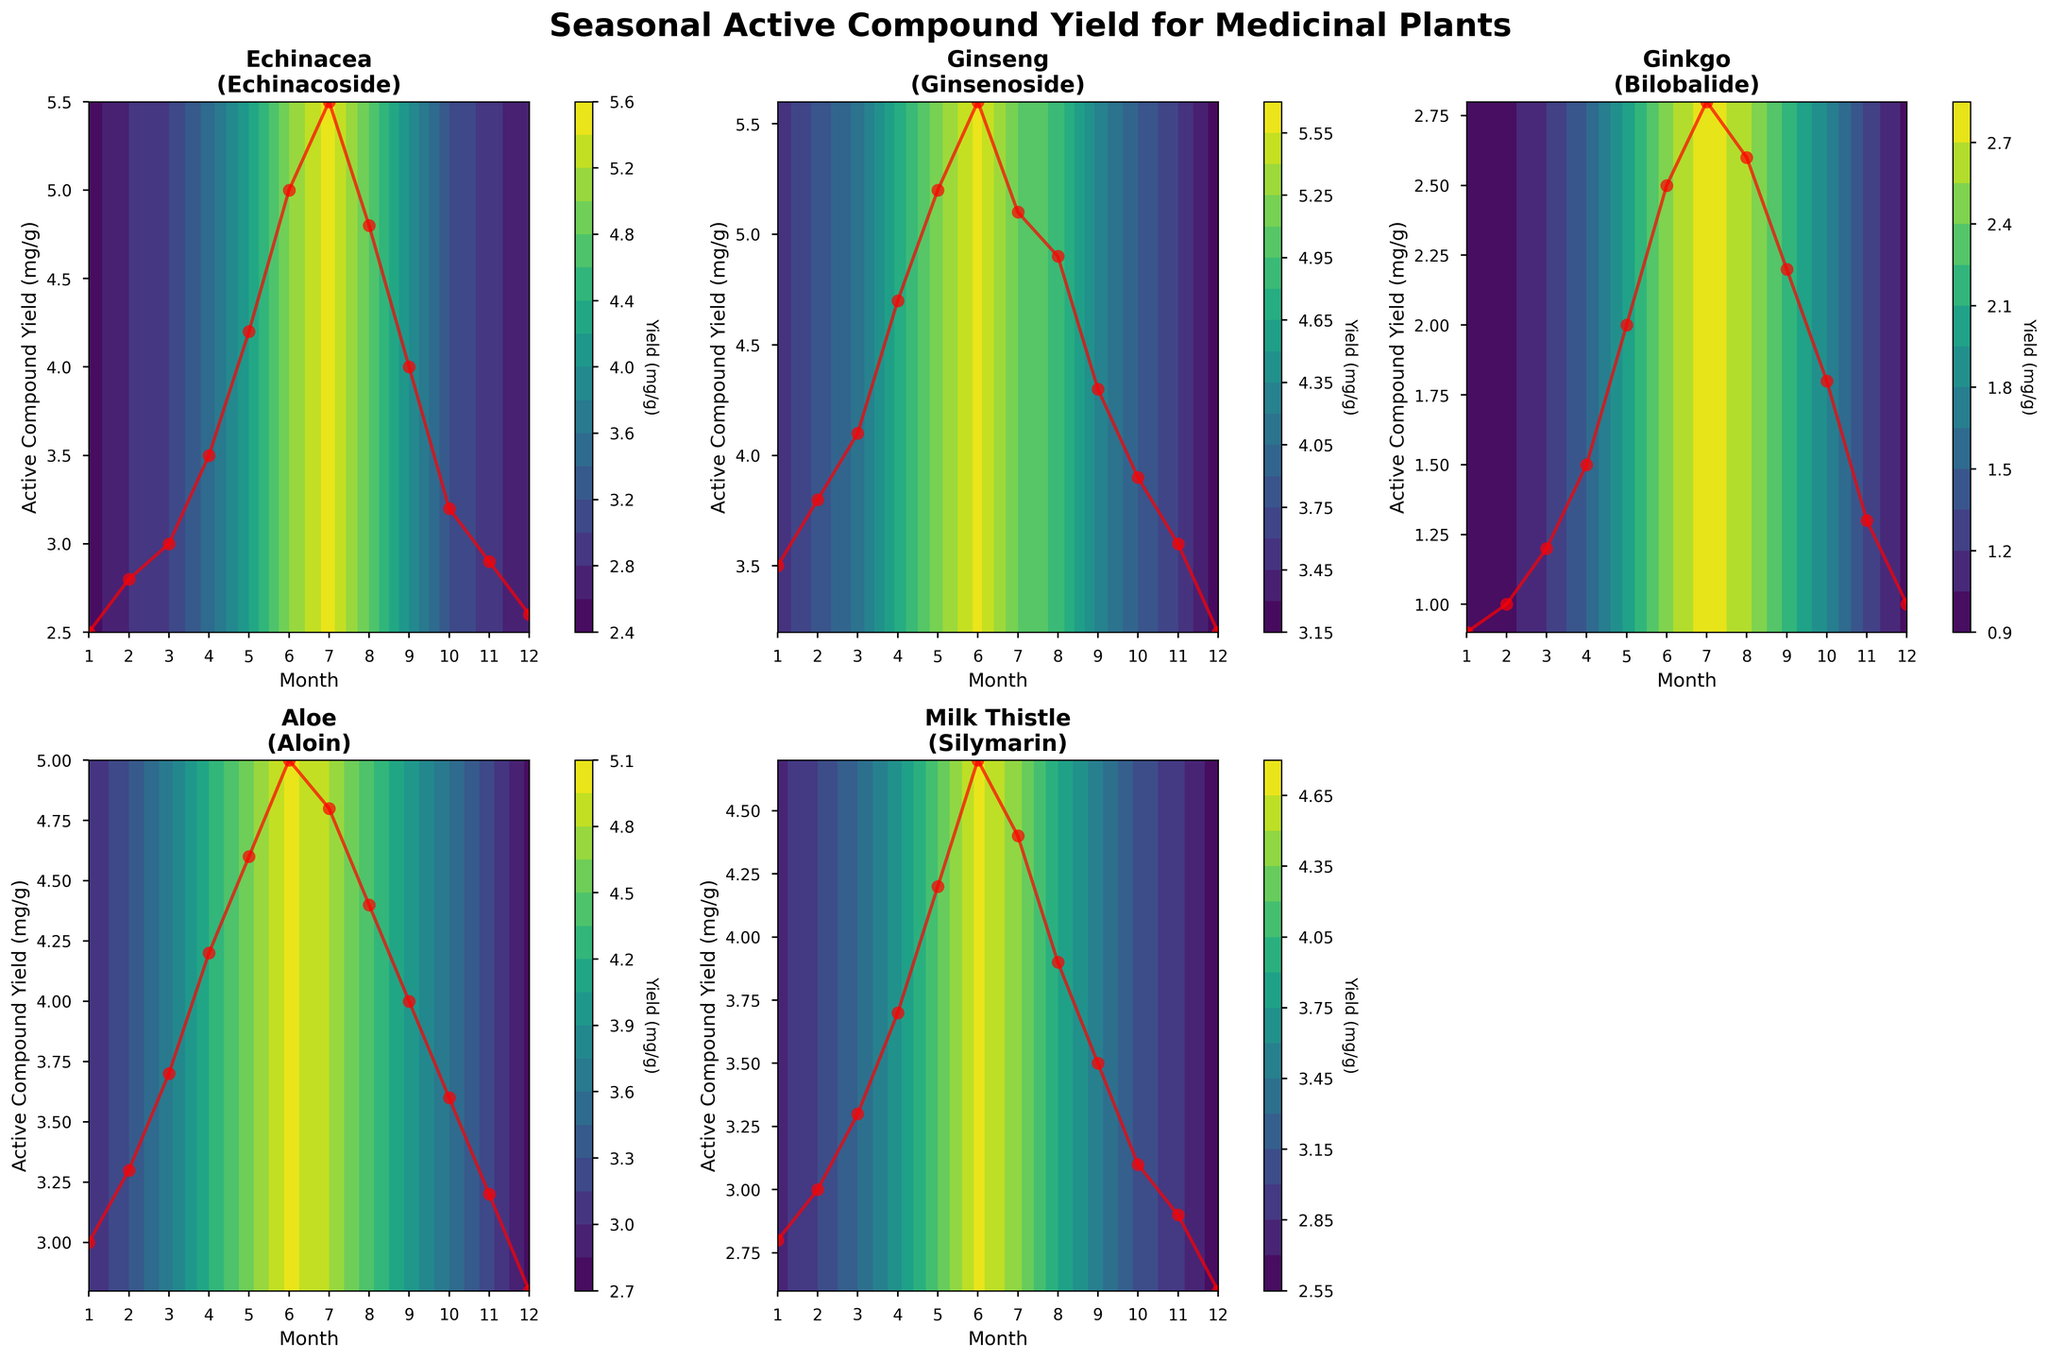How many medicinal plants are plotted in the figure? The figure has subplots for Echinacea, Ginseng, Ginkgo, Aloe, and Milk Thistle, totaling five medicinal plants.
Answer: 5 Which medicinal plant has the highest peak yield of its active compound? By looking at the peaks in the subplots, Echinacea and Ginseng both peak at around 5.5 mg/g and 5.6 mg/g, respectively. Ginseng's yield is slightly higher.
Answer: Ginseng What is the range of the active compound yield for Milk Thistle? The range can be determined by the minimum and maximum values on the y-axis of the subplot for Milk Thistle. The minimum yield is around 2.6 mg/g, and the maximum is around 4.7 mg/g.
Answer: 2.6 to 4.7 mg/g During which month does Aloe have its highest active compound yield? From the subplot for Aloe, the peak yield appears around June, which corresponds to month 6 on the x-axis.
Answer: June Which month generally sees a decrease in the active compound yield for most plants? By observing the trends across all subplots, it is evident that yields for Echinacea, Ginseng, Ginkgo, Aloe, and Milk Thistle generally decrease after their peak in June or July.
Answer: After July How does the yield of Bilobalide in Ginkgo change from January to December? The subplot for Ginkgo shows an overall increase in yield from January with 0.9 mg/g, peaking in July with 2.8 mg/g, and then a gradual decrease to 1.0 mg/g in December.
Answer: Increases then decreases During which month is Silymarin's yield at its lowest in Milk Thistle? In the subplot for Milk Thistle, the lowest yield occurs around December, where the yield is approximately 2.6 mg/g.
Answer: December For which plant does the yield of the active compound remain consistently high for more months? Comparing the subplots, Ginseng (Ginsenoside) and Echinacea (Echinacoside) have relatively high yields for a longer period, particularly between May and August.
Answer: Ginseng Compare the trend of active compound yield for Echinacea and Aloe from month 1 to month 12. For Echinacea, the yield increases steadily from January, peaks around July, and then decreases. For Aloe, a similar trend is observed with a peak around June, followed by a decline.
Answer: Similar trend Which plant exhibits the most dramatic change in active compound yield throughout the year? Observing the subplots, Ginkgo shows a significant and dramatic increase and decrease with a peak in middle months, from 0.9 mg/g in January to 2.8 mg/g in July.
Answer: Ginkgo 